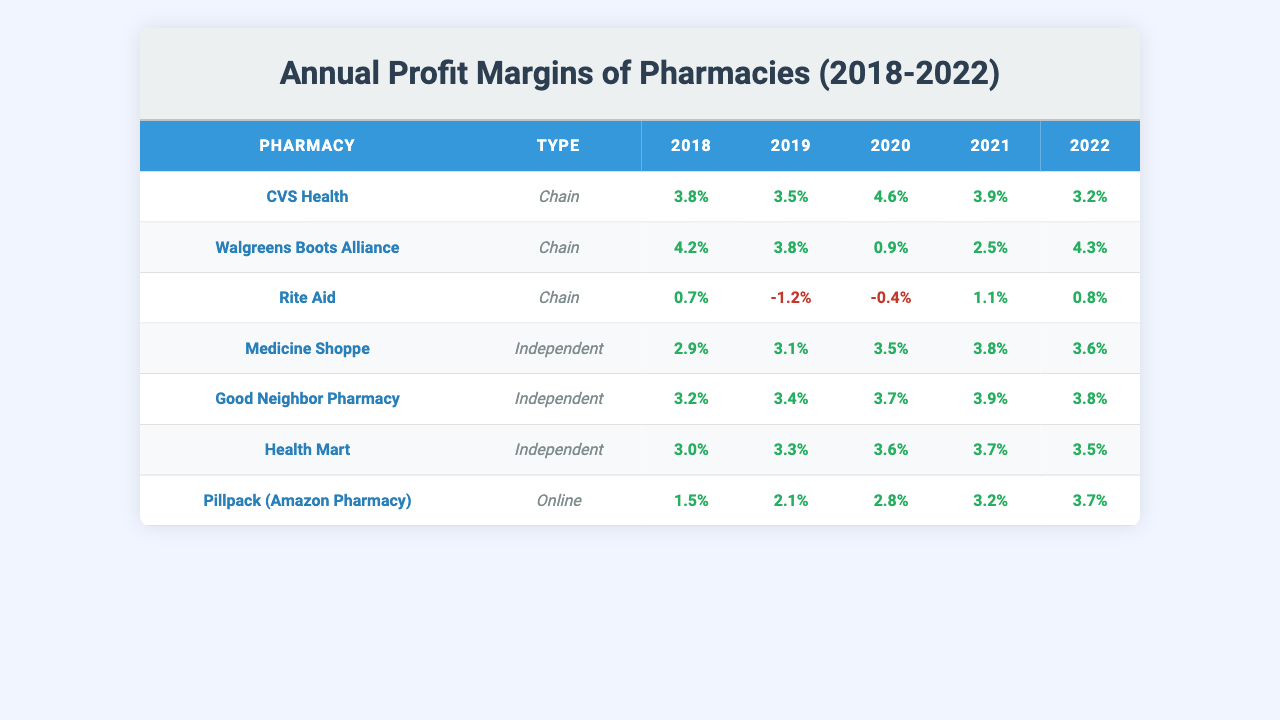What were the profit margins of CVS Health in 2021? From the table, CVS Health's profit margin for the year 2021 is listed as 3.9%.
Answer: 3.9% Which independent pharmacy had the highest profit margin in 2022? By checking the 2022 profit margin values for independent pharmacies, Good Neighbor Pharmacy has the highest at 3.8%.
Answer: Good Neighbor Pharmacy What was the average profit margin for Walgreens Boots Alliance from 2018 to 2022? To find the average, sum the profit margins: (4.2 + 3.8 + 0.9 + 2.5 + 4.3) = 15.7. Then, divide by 5 (the number of years): 15.7 / 5 = 3.14%.
Answer: 3.14% Did any independent pharmacy experience a profit margin above 3.5% in all years from 2018 to 2022? Reviewing the profit margins for all independent pharmacies, both Medicine Shoppe and Good Neighbor Pharmacy exceeded 3.5% every year.
Answer: Yes What is the difference in profit margins between the best-performing and worst-performing chain pharmacy in 2020? CVS Health had a profit margin of 4.6%, while Rite Aid had -0.4%. The difference is 4.6 - (-0.4) = 5.0%.
Answer: 5.0% Which type of pharmacy had the most significant decline in profit margins from 2018 to 2021? Analyzing the data, Rite Aid (Chain) decreased from 0.7% in 2018 to 1.1% in 2021, while independent pharmacies like Medicine Shoppe showed a smaller decline, indicating Rite Aid faced the most significant decline.
Answer: Chain pharmacies Is it true that all independent pharmacies had profit margins above 3% in 2020? Checking the 2020 profit margins: Medicine Shoppe (3.5%), Good Neighbor Pharmacy (3.7%), and Health Mart (3.6%) all exceeded 3%, confirming the statement is true.
Answer: Yes What was the trend of profit margins for chain pharmacies from 2018 to 2022? Reviewing the margins: CVS fluctuated, Walgreens declined and then increased, while Rite Aid generally worsened, indicating an overall mixed trend with fluctuations and declines.
Answer: Mixed trend with fluctuations Which pharmacy type (independent or chain) had a better average profit margin in 2022? The average for independent pharmacies in 2022 is (3.6 + 3.8 + 3.5) = 3.633%, and for chain pharmacies it is (3.2 + 4.3 + 0.8) = 2.433%. Thus, independent pharmacies had a better average margin.
Answer: Independent pharmacies How many years did Rite Aid have a negative profit margin in the given data? Rite Aid had negative profit margins in 2019 and 2020, which totals two years.
Answer: 2 years 